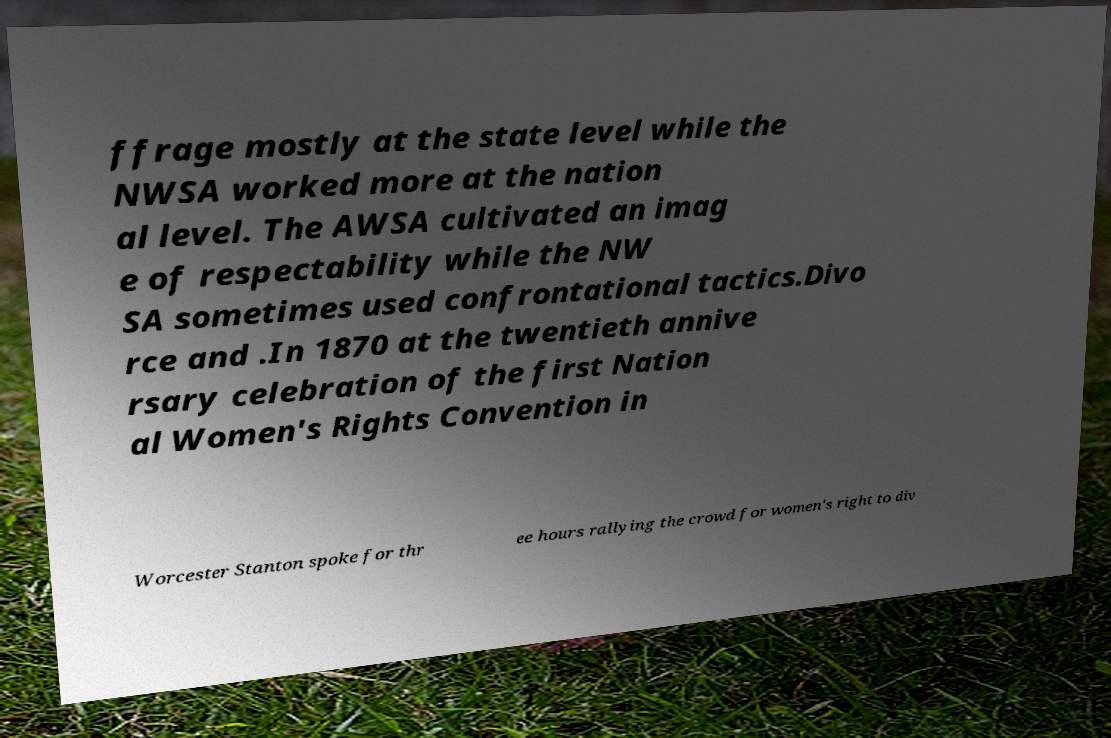What messages or text are displayed in this image? I need them in a readable, typed format. ffrage mostly at the state level while the NWSA worked more at the nation al level. The AWSA cultivated an imag e of respectability while the NW SA sometimes used confrontational tactics.Divo rce and .In 1870 at the twentieth annive rsary celebration of the first Nation al Women's Rights Convention in Worcester Stanton spoke for thr ee hours rallying the crowd for women's right to div 